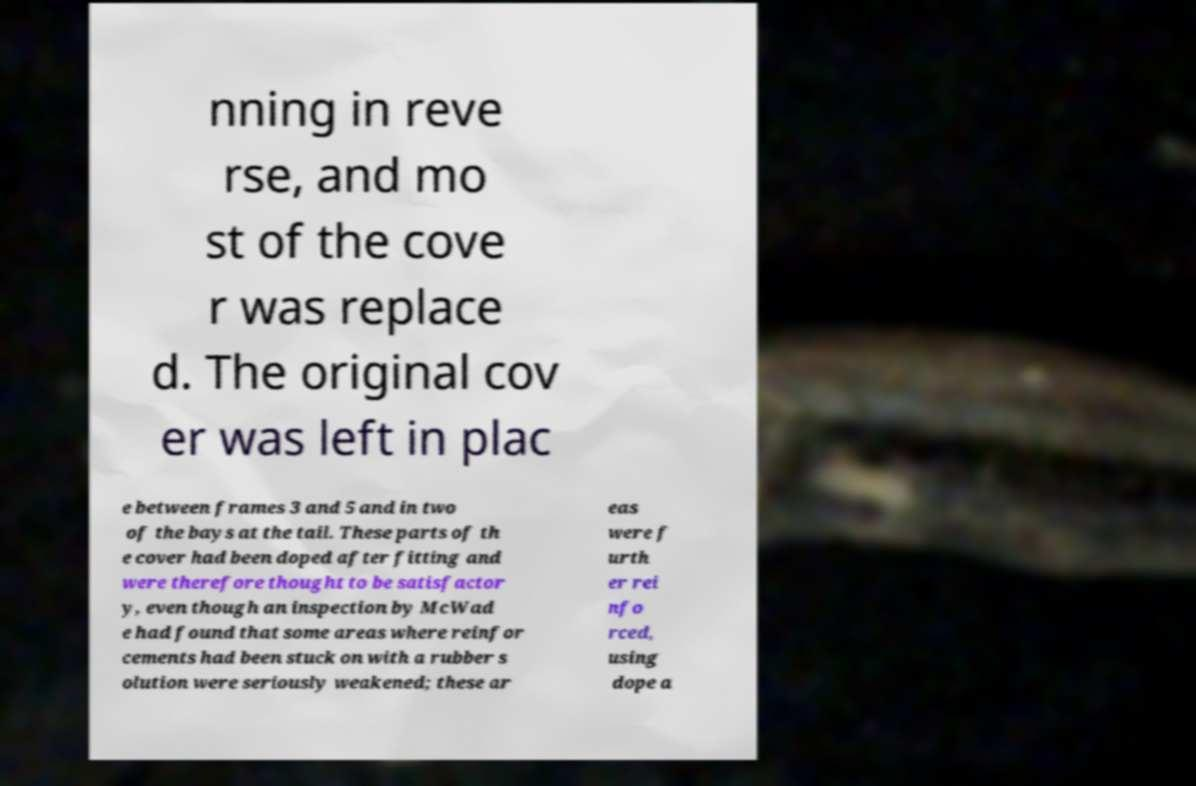Can you accurately transcribe the text from the provided image for me? nning in reve rse, and mo st of the cove r was replace d. The original cov er was left in plac e between frames 3 and 5 and in two of the bays at the tail. These parts of th e cover had been doped after fitting and were therefore thought to be satisfactor y, even though an inspection by McWad e had found that some areas where reinfor cements had been stuck on with a rubber s olution were seriously weakened; these ar eas were f urth er rei nfo rced, using dope a 